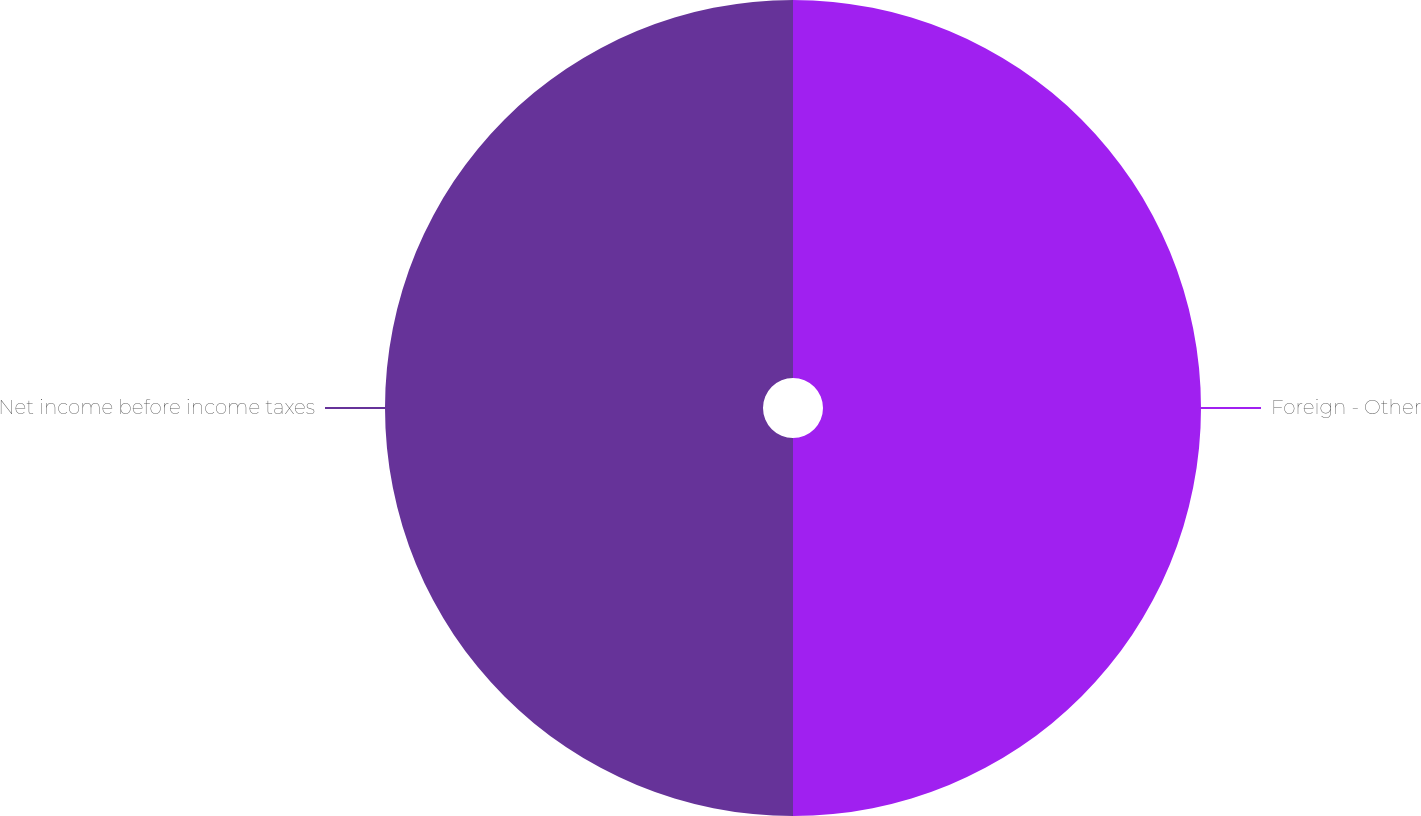Convert chart. <chart><loc_0><loc_0><loc_500><loc_500><pie_chart><fcel>Foreign - Other<fcel>Net income before income taxes<nl><fcel>50.0%<fcel>50.0%<nl></chart> 